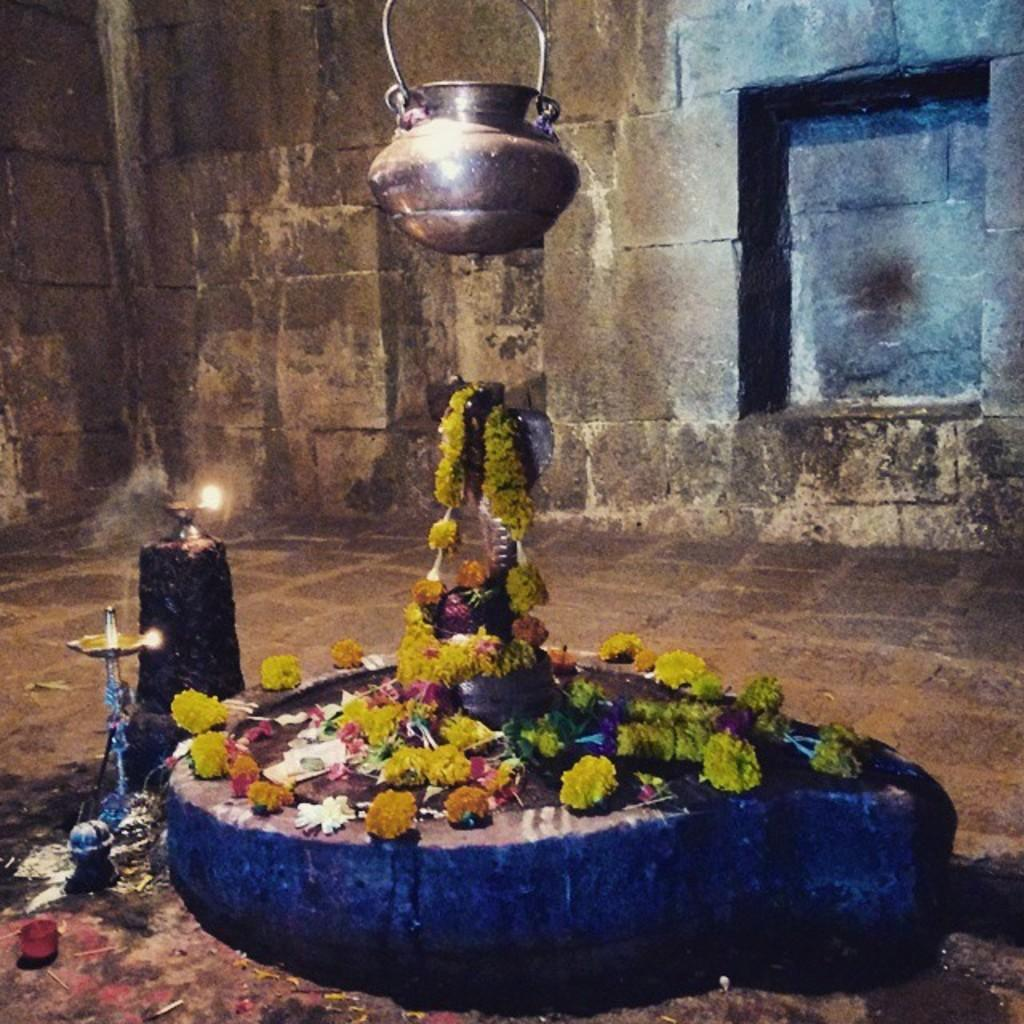What is the main subject of the image? There is a statue of a god in the image. What can be seen around the statue? There are objects around the statue. What type of decorations are present in the image? There are flowers and diyas in the image. What is the background of the image? There is a wall in the image. Where is the vessel located in the image? There is a vessel at the top of the image. How many trees are visible in the image? There are no trees visible in the image. What type of structure is the sheet used for in the image? There is no sheet present in the image. 